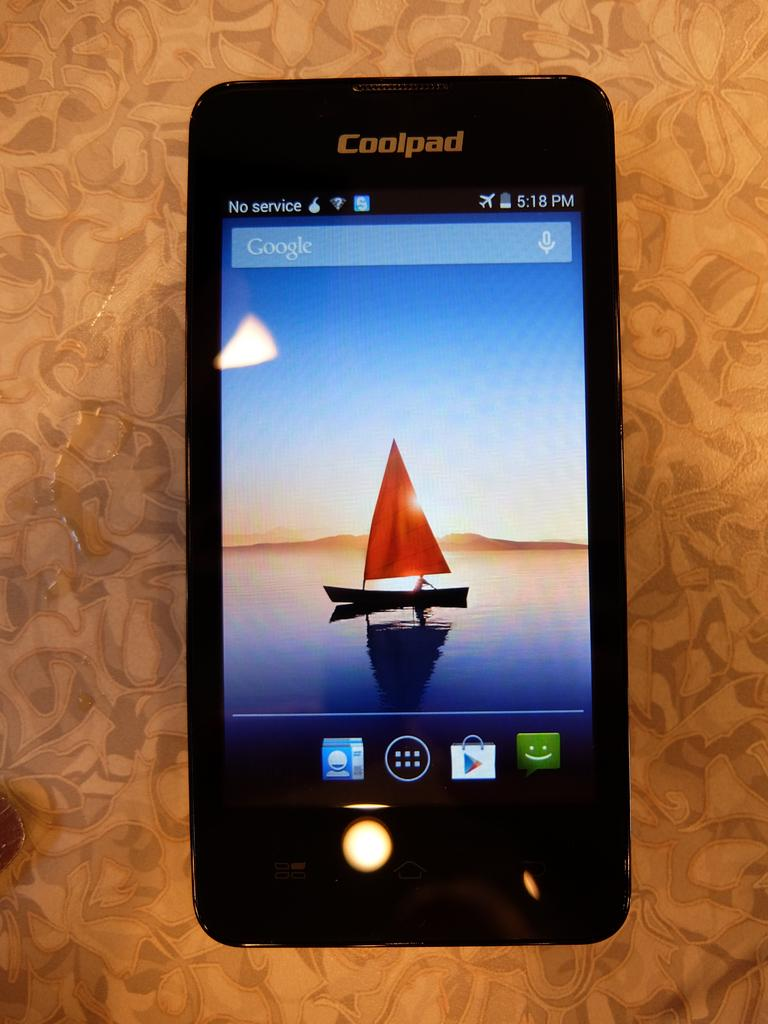Provide a one-sentence caption for the provided image. A Coolpad ssmartphone has a Google Search bar on the screen and shows the time as 5:18 pm. 